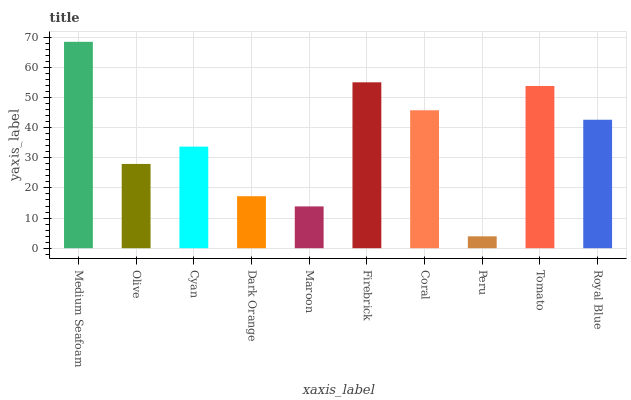Is Peru the minimum?
Answer yes or no. Yes. Is Medium Seafoam the maximum?
Answer yes or no. Yes. Is Olive the minimum?
Answer yes or no. No. Is Olive the maximum?
Answer yes or no. No. Is Medium Seafoam greater than Olive?
Answer yes or no. Yes. Is Olive less than Medium Seafoam?
Answer yes or no. Yes. Is Olive greater than Medium Seafoam?
Answer yes or no. No. Is Medium Seafoam less than Olive?
Answer yes or no. No. Is Royal Blue the high median?
Answer yes or no. Yes. Is Cyan the low median?
Answer yes or no. Yes. Is Cyan the high median?
Answer yes or no. No. Is Medium Seafoam the low median?
Answer yes or no. No. 